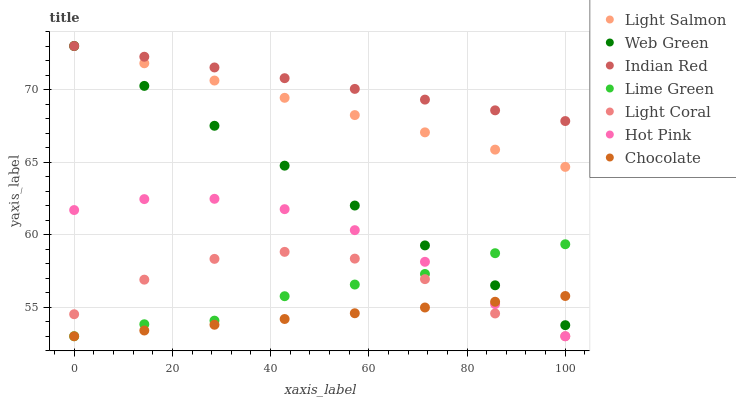Does Chocolate have the minimum area under the curve?
Answer yes or no. Yes. Does Indian Red have the maximum area under the curve?
Answer yes or no. Yes. Does Hot Pink have the minimum area under the curve?
Answer yes or no. No. Does Hot Pink have the maximum area under the curve?
Answer yes or no. No. Is Chocolate the smoothest?
Answer yes or no. Yes. Is Light Coral the roughest?
Answer yes or no. Yes. Is Hot Pink the smoothest?
Answer yes or no. No. Is Hot Pink the roughest?
Answer yes or no. No. Does Hot Pink have the lowest value?
Answer yes or no. Yes. Does Web Green have the lowest value?
Answer yes or no. No. Does Indian Red have the highest value?
Answer yes or no. Yes. Does Hot Pink have the highest value?
Answer yes or no. No. Is Light Coral less than Indian Red?
Answer yes or no. Yes. Is Indian Red greater than Hot Pink?
Answer yes or no. Yes. Does Chocolate intersect Lime Green?
Answer yes or no. Yes. Is Chocolate less than Lime Green?
Answer yes or no. No. Is Chocolate greater than Lime Green?
Answer yes or no. No. Does Light Coral intersect Indian Red?
Answer yes or no. No. 